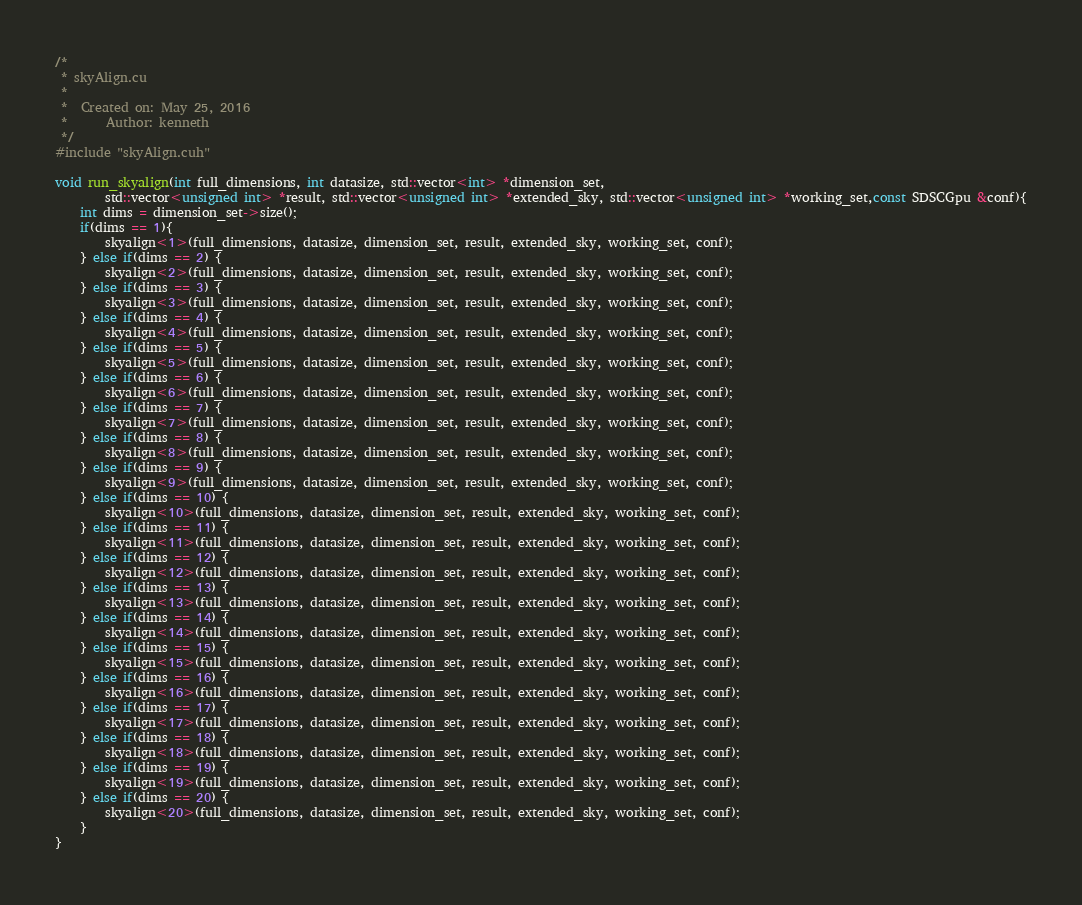Convert code to text. <code><loc_0><loc_0><loc_500><loc_500><_Cuda_>/*
 * skyAlign.cu
 *
 *  Created on: May 25, 2016
 *      Author: kenneth
 */
#include "skyAlign.cuh"

void run_skyalign(int full_dimensions, int datasize, std::vector<int> *dimension_set,
		std::vector<unsigned int> *result, std::vector<unsigned int> *extended_sky, std::vector<unsigned int> *working_set,const SDSCGpu &conf){
	int dims = dimension_set->size();
	if(dims == 1){
		skyalign<1>(full_dimensions, datasize, dimension_set, result, extended_sky, working_set, conf);
	} else if(dims == 2) {
		skyalign<2>(full_dimensions, datasize, dimension_set, result, extended_sky, working_set, conf);
	} else if(dims == 3) {
		skyalign<3>(full_dimensions, datasize, dimension_set, result, extended_sky, working_set, conf);
	} else if(dims == 4) {
		skyalign<4>(full_dimensions, datasize, dimension_set, result, extended_sky, working_set, conf);
	} else if(dims == 5) {
		skyalign<5>(full_dimensions, datasize, dimension_set, result, extended_sky, working_set, conf);
	} else if(dims == 6) {
		skyalign<6>(full_dimensions, datasize, dimension_set, result, extended_sky, working_set, conf);
	} else if(dims == 7) {
		skyalign<7>(full_dimensions, datasize, dimension_set, result, extended_sky, working_set, conf);
	} else if(dims == 8) {
		skyalign<8>(full_dimensions, datasize, dimension_set, result, extended_sky, working_set, conf);
	} else if(dims == 9) {
		skyalign<9>(full_dimensions, datasize, dimension_set, result, extended_sky, working_set, conf);
	} else if(dims == 10) {
		skyalign<10>(full_dimensions, datasize, dimension_set, result, extended_sky, working_set, conf);
	} else if(dims == 11) {
		skyalign<11>(full_dimensions, datasize, dimension_set, result, extended_sky, working_set, conf);
	} else if(dims == 12) {
		skyalign<12>(full_dimensions, datasize, dimension_set, result, extended_sky, working_set, conf);
	} else if(dims == 13) {
		skyalign<13>(full_dimensions, datasize, dimension_set, result, extended_sky, working_set, conf);
	} else if(dims == 14) {
		skyalign<14>(full_dimensions, datasize, dimension_set, result, extended_sky, working_set, conf);
	} else if(dims == 15) {
		skyalign<15>(full_dimensions, datasize, dimension_set, result, extended_sky, working_set, conf);
	} else if(dims == 16) {
		skyalign<16>(full_dimensions, datasize, dimension_set, result, extended_sky, working_set, conf);
	} else if(dims == 17) {
		skyalign<17>(full_dimensions, datasize, dimension_set, result, extended_sky, working_set, conf);
	} else if(dims == 18) {
		skyalign<18>(full_dimensions, datasize, dimension_set, result, extended_sky, working_set, conf);
	} else if(dims == 19) {
		skyalign<19>(full_dimensions, datasize, dimension_set, result, extended_sky, working_set, conf);
	} else if(dims == 20) {
		skyalign<20>(full_dimensions, datasize, dimension_set, result, extended_sky, working_set, conf);
	}
}



</code> 